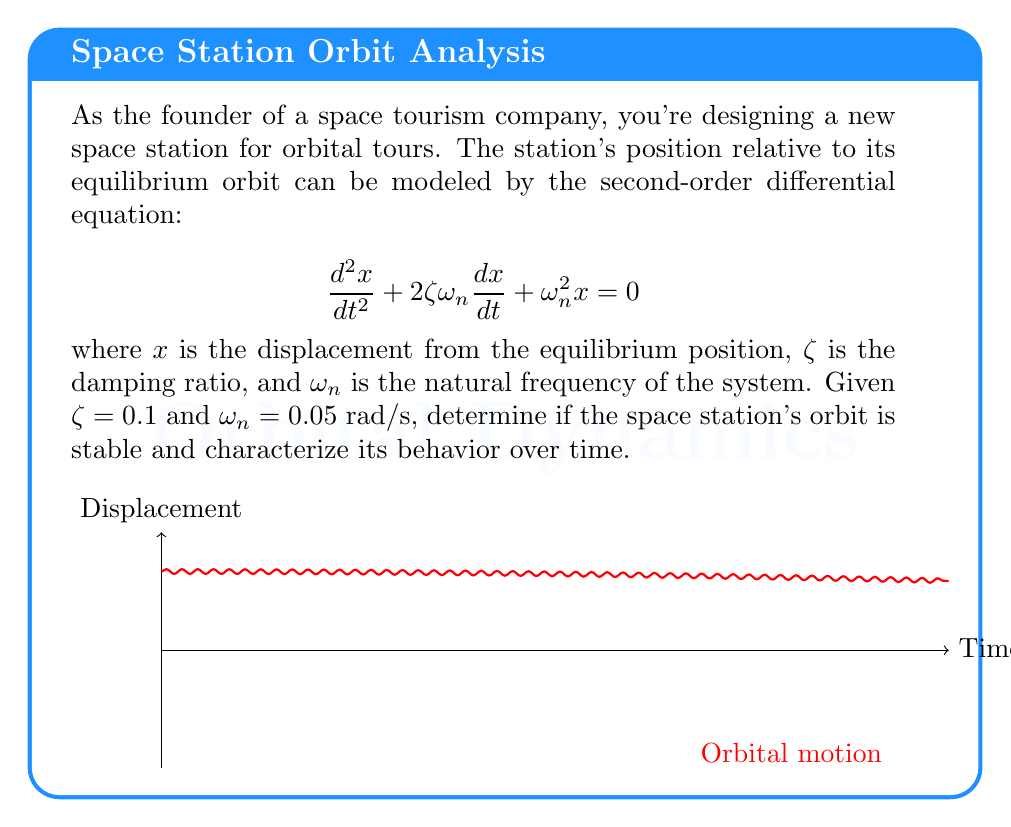Show me your answer to this math problem. To analyze the stability of the space station's orbit, we need to follow these steps:

1) The characteristic equation of the given second-order differential equation is:
   $$s^2 + 2\zeta\omega_n s + \omega_n^2 = 0$$

2) Substituting the given values:
   $$s^2 + 2(0.1)(0.05)s + 0.05^2 = 0$$
   $$s^2 + 0.01s + 0.0025 = 0$$

3) Solving this quadratic equation:
   $$s = \frac{-0.01 \pm \sqrt{0.01^2 - 4(1)(0.0025)}}{2(1)}$$
   $$s = -0.005 \pm 0.0499i$$

4) The general solution of the differential equation is:
   $$x(t) = e^{-0.005t}(A\cos(0.0499t) + B\sin(0.0499t))$$
   where A and B are constants determined by initial conditions.

5) Stability analysis:
   - The real part of the complex roots is negative (-0.005).
   - This indicates that the system is stable, as the amplitude will decay over time.

6) Behavior characterization:
   - The system exhibits underdamped oscillations.
   - The oscillations will decay exponentially with a time constant of 1/0.005 = 200 seconds.
   - The oscillation frequency is 0.0499 rad/s, or about 0.00794 Hz.

7) The displacement will oscillate around the equilibrium position with decreasing amplitude, eventually settling at the equilibrium orbit.
Answer: Stable; underdamped oscillations with exponential decay. 